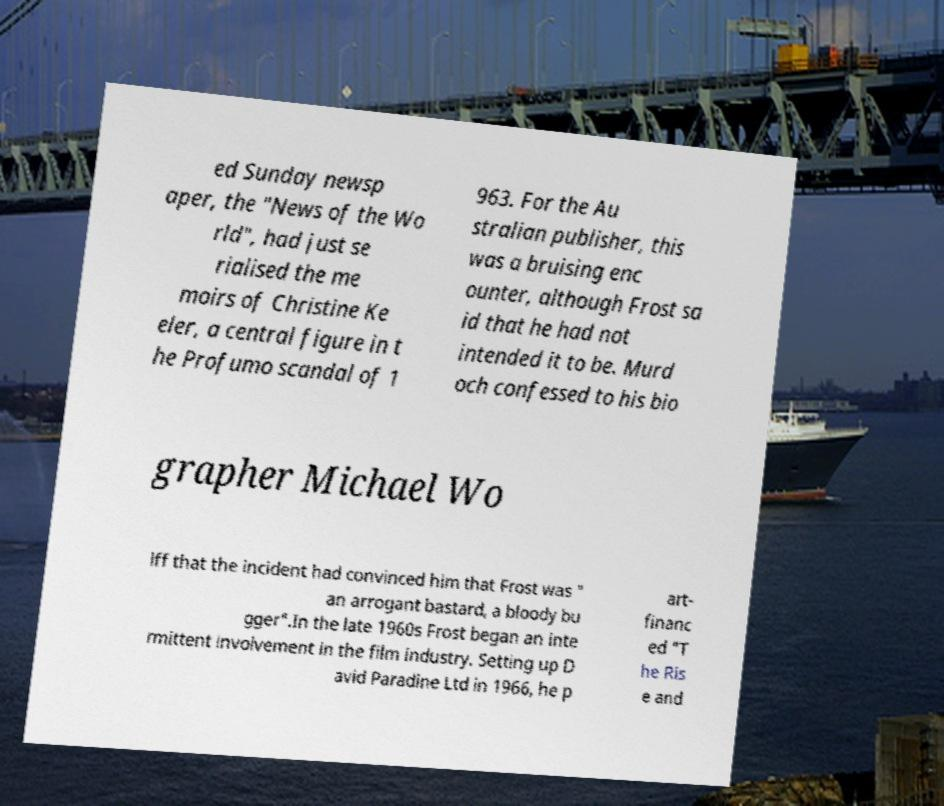Can you read and provide the text displayed in the image?This photo seems to have some interesting text. Can you extract and type it out for me? ed Sunday newsp aper, the "News of the Wo rld", had just se rialised the me moirs of Christine Ke eler, a central figure in t he Profumo scandal of 1 963. For the Au stralian publisher, this was a bruising enc ounter, although Frost sa id that he had not intended it to be. Murd och confessed to his bio grapher Michael Wo lff that the incident had convinced him that Frost was " an arrogant bastard, a bloody bu gger".In the late 1960s Frost began an inte rmittent involvement in the film industry. Setting up D avid Paradine Ltd in 1966, he p art- financ ed "T he Ris e and 